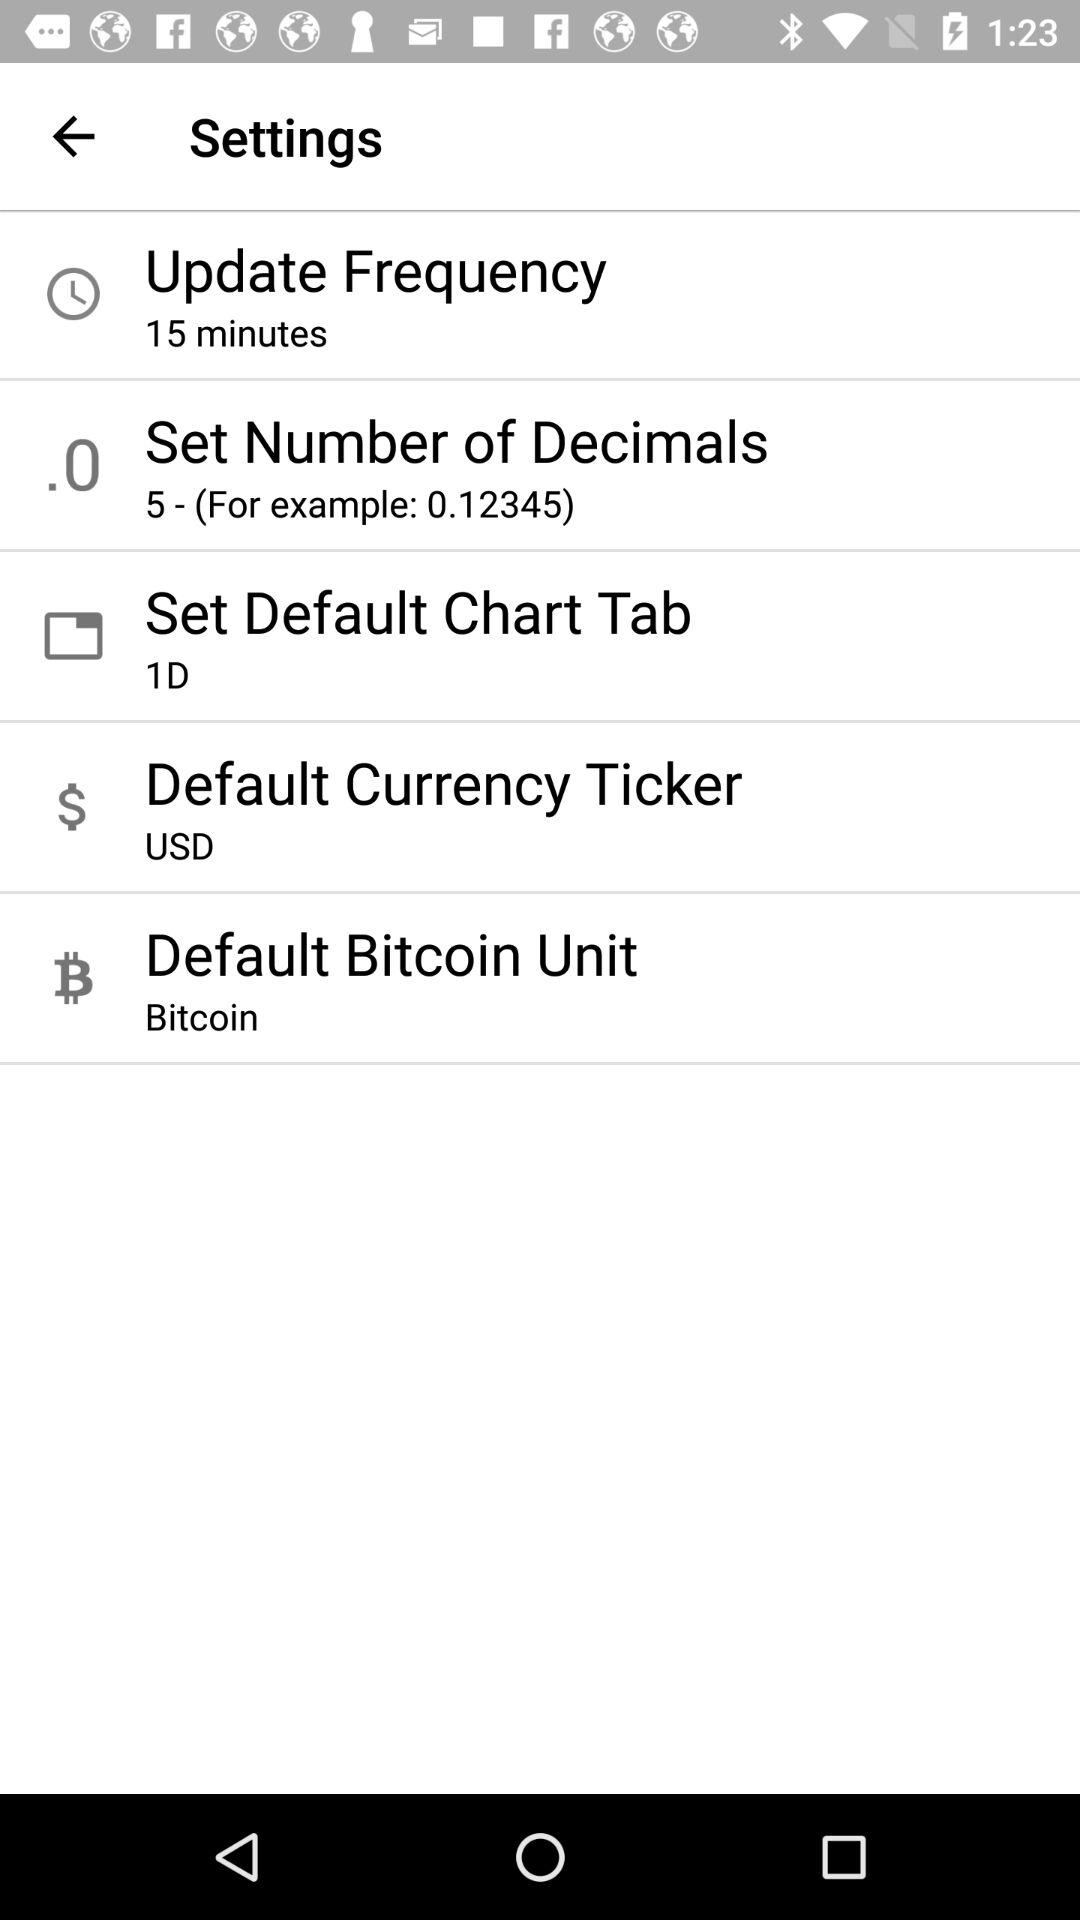What's the set number of decimals? The set number of decimals is 5. 